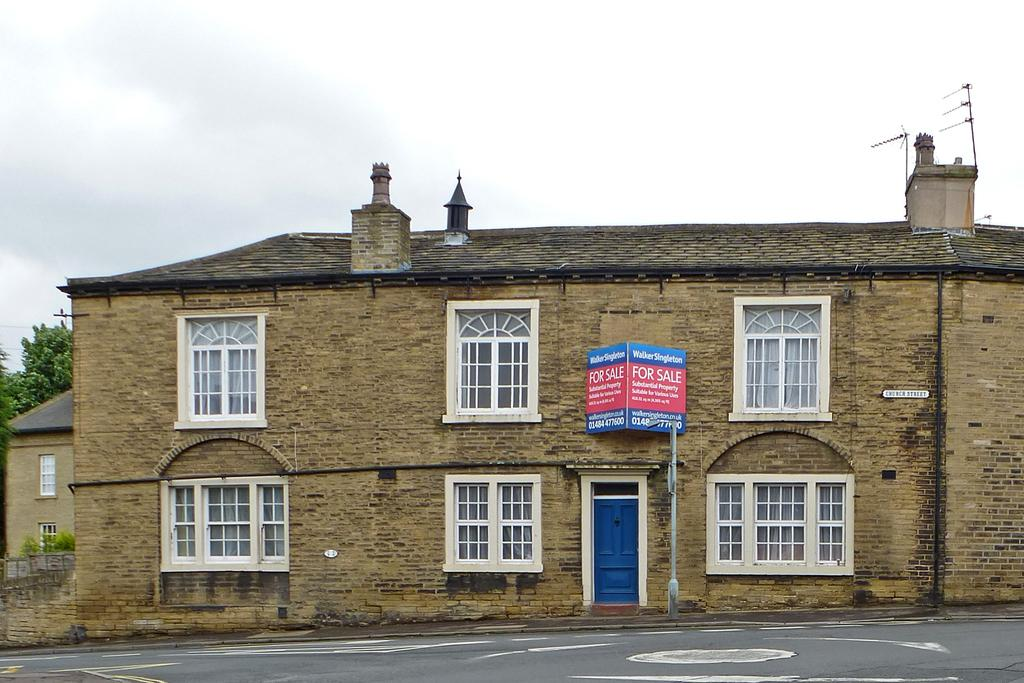What is located at the bottom of the image? There is a road at the bottom of the image. What structure can be seen in the background of the image? There is a house in the background of the image. What is visible at the top of the image? The sky is visible at the top of the image. How many chickens are present in the image? There are no chickens present in the image. What type of slave can be seen working in the background of the image? There is no slave present in the image; it only features a road, a house, and the sky. 